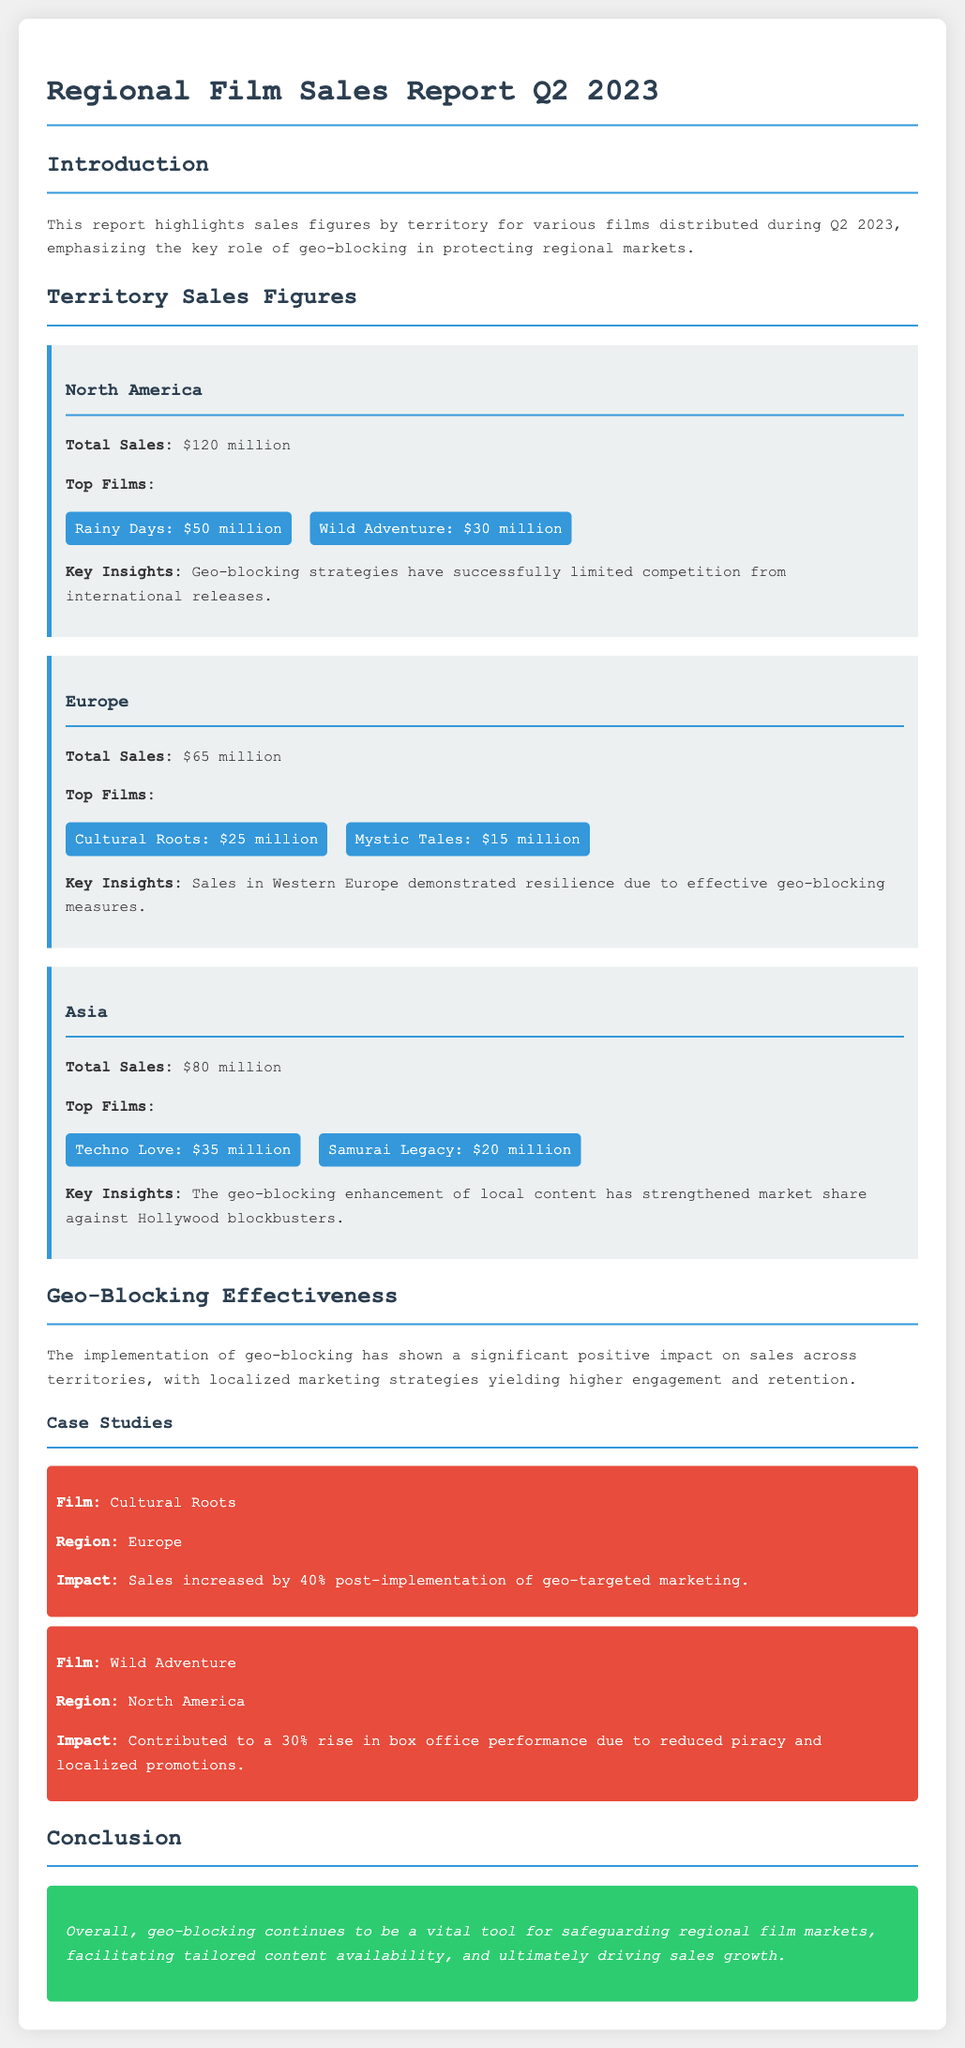What is the total sales figure for North America? The total sales figure for North America is highlighted in the document as $120 million.
Answer: $120 million What are the top films in Europe? The document lists the top films in Europe along with their sales figures: Cultural Roots and Mystic Tales.
Answer: Cultural Roots, Mystic Tales What percentage increase in sales was observed for Cultural Roots after geo-targeted marketing? The document specifically states a 40% increase in sales for Cultural Roots following the implementation.
Answer: 40% Which territory showed a total sales figure of $80 million? The document clearly indicates that Asia had total sales of $80 million.
Answer: Asia What impact did geo-blocking have on Wild Adventure in North America? The report mentions that geo-blocking contributed to a 30% rise in box office performance for Wild Adventure due to reduced piracy and localized promotions.
Answer: 30% rise in box office performance What is the main purpose of geo-blocking according to the report? The document emphasizes that the main purpose of geo-blocking is to safeguard regional film markets and drive sales growth.
Answer: Safeguard regional film markets What were the total sales figures for Europe? The document provides the total sales figure for Europe, which is $65 million.
Answer: $65 million What was the top film in North America and its sales figure? The document points out that the top film in North America is Rainy Days, which generated $50 million in sales.
Answer: Rainy Days: $50 million What key insight does the report provide about sales in Western Europe? The document notes that sales in Western Europe demonstrated resilience due to effective geo-blocking measures.
Answer: Resilience due to effective geo-blocking measures 